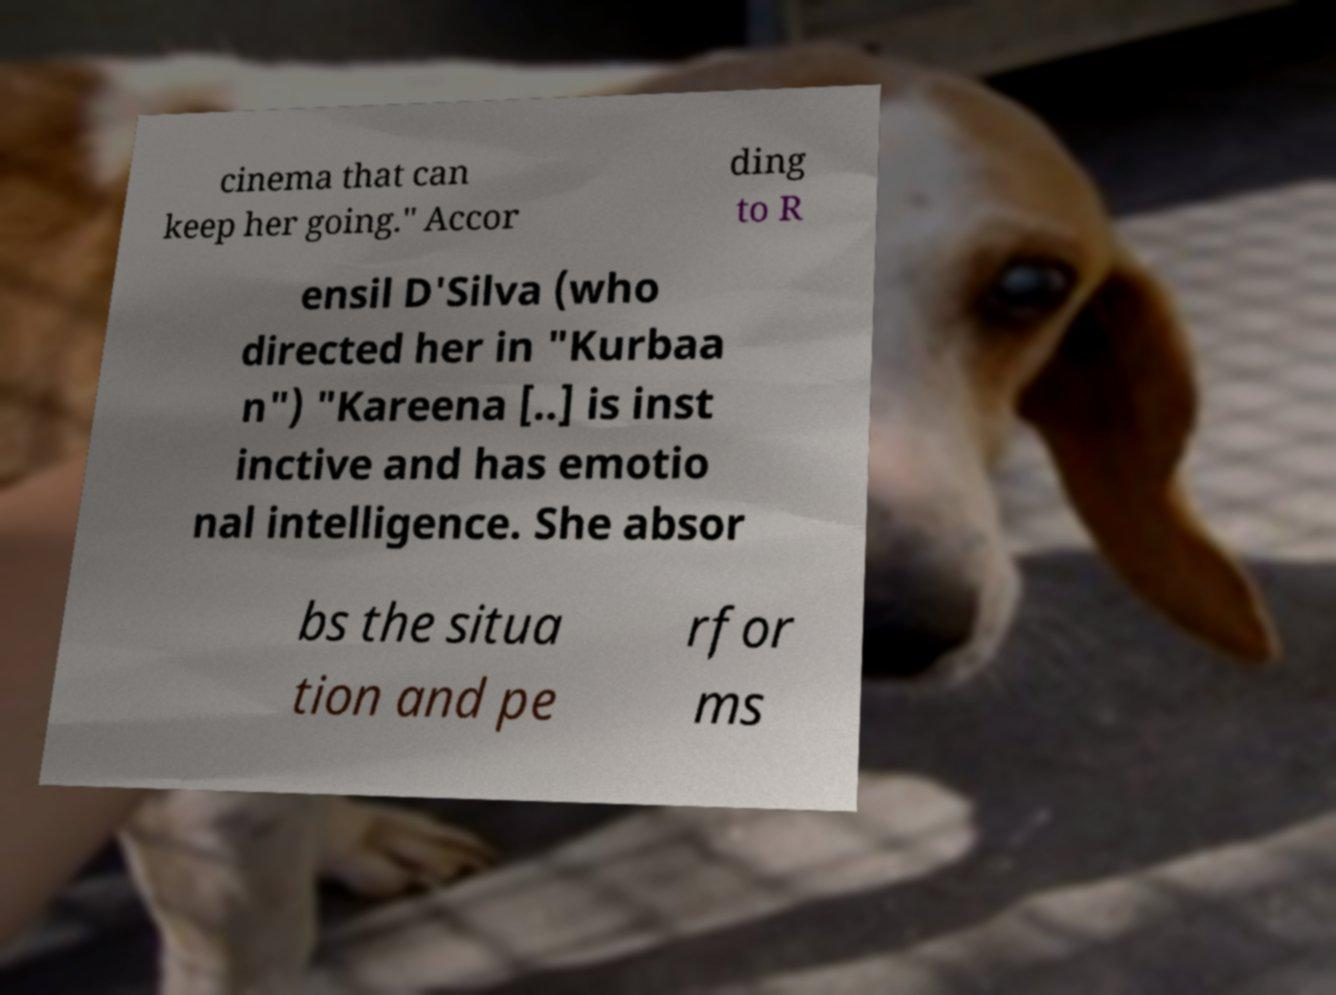Can you read and provide the text displayed in the image?This photo seems to have some interesting text. Can you extract and type it out for me? cinema that can keep her going." Accor ding to R ensil D'Silva (who directed her in "Kurbaa n") "Kareena [..] is inst inctive and has emotio nal intelligence. She absor bs the situa tion and pe rfor ms 